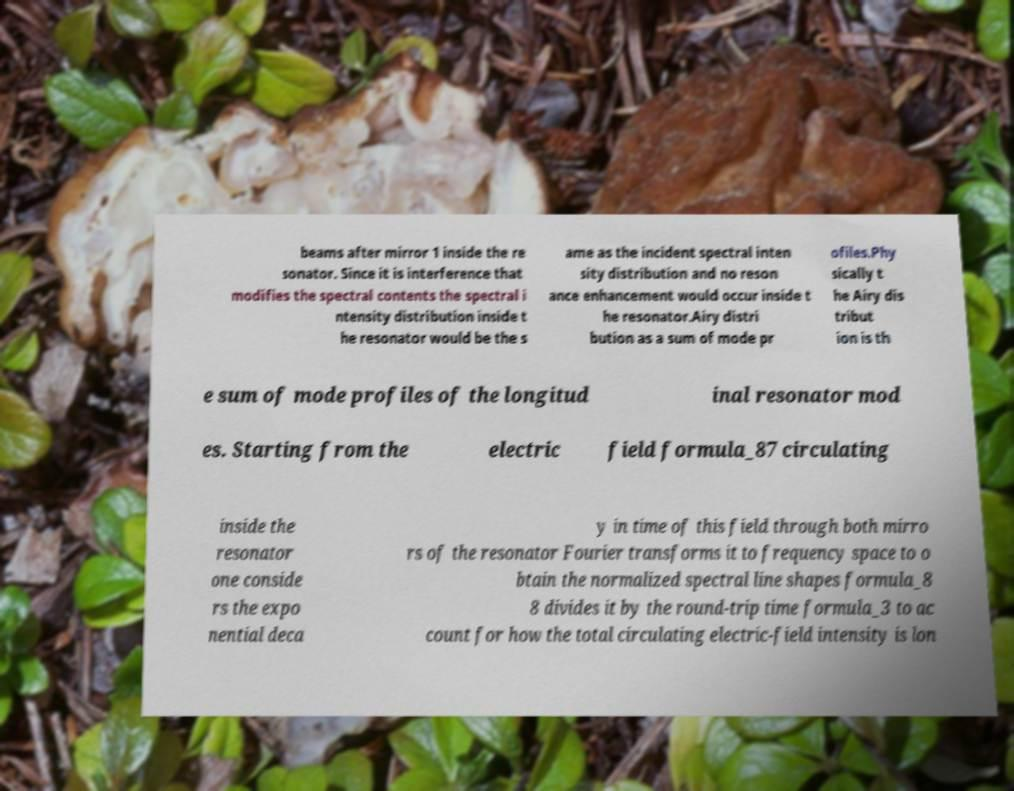Please identify and transcribe the text found in this image. beams after mirror 1 inside the re sonator. Since it is interference that modifies the spectral contents the spectral i ntensity distribution inside t he resonator would be the s ame as the incident spectral inten sity distribution and no reson ance enhancement would occur inside t he resonator.Airy distri bution as a sum of mode pr ofiles.Phy sically t he Airy dis tribut ion is th e sum of mode profiles of the longitud inal resonator mod es. Starting from the electric field formula_87 circulating inside the resonator one conside rs the expo nential deca y in time of this field through both mirro rs of the resonator Fourier transforms it to frequency space to o btain the normalized spectral line shapes formula_8 8 divides it by the round-trip time formula_3 to ac count for how the total circulating electric-field intensity is lon 